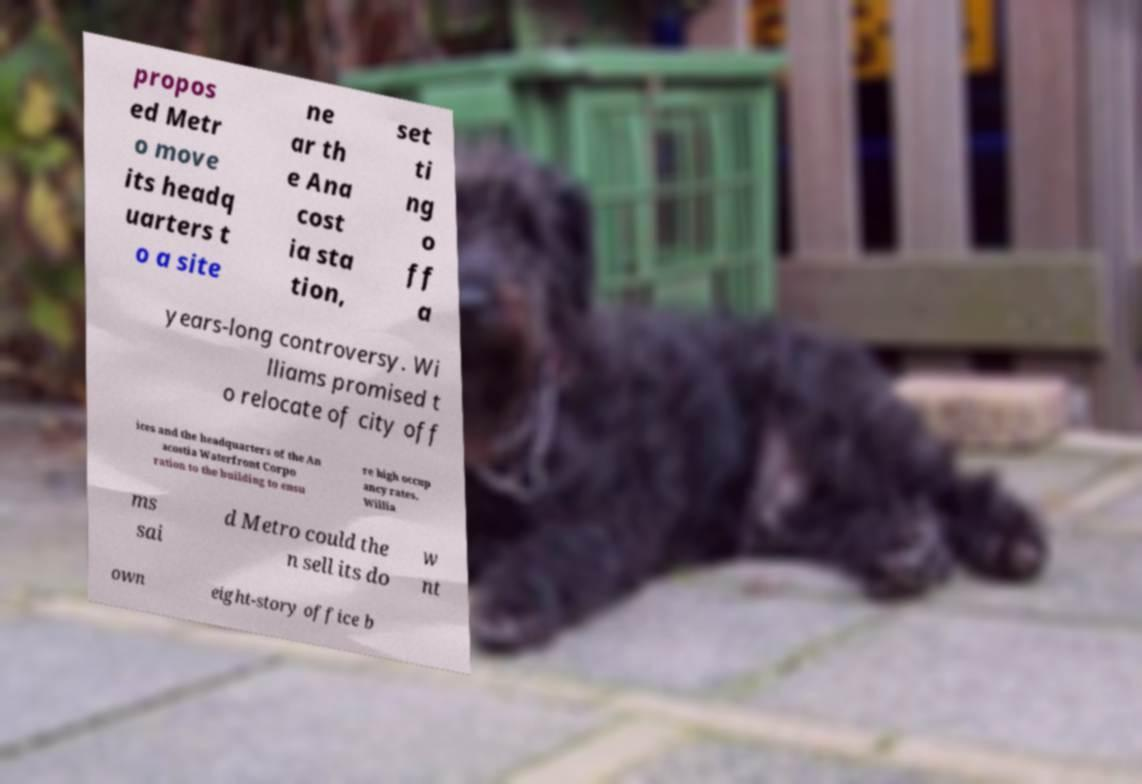Could you assist in decoding the text presented in this image and type it out clearly? propos ed Metr o move its headq uarters t o a site ne ar th e Ana cost ia sta tion, set ti ng o ff a years-long controversy. Wi lliams promised t o relocate of city off ices and the headquarters of the An acostia Waterfront Corpo ration to the building to ensu re high occup ancy rates. Willia ms sai d Metro could the n sell its do w nt own eight-story office b 